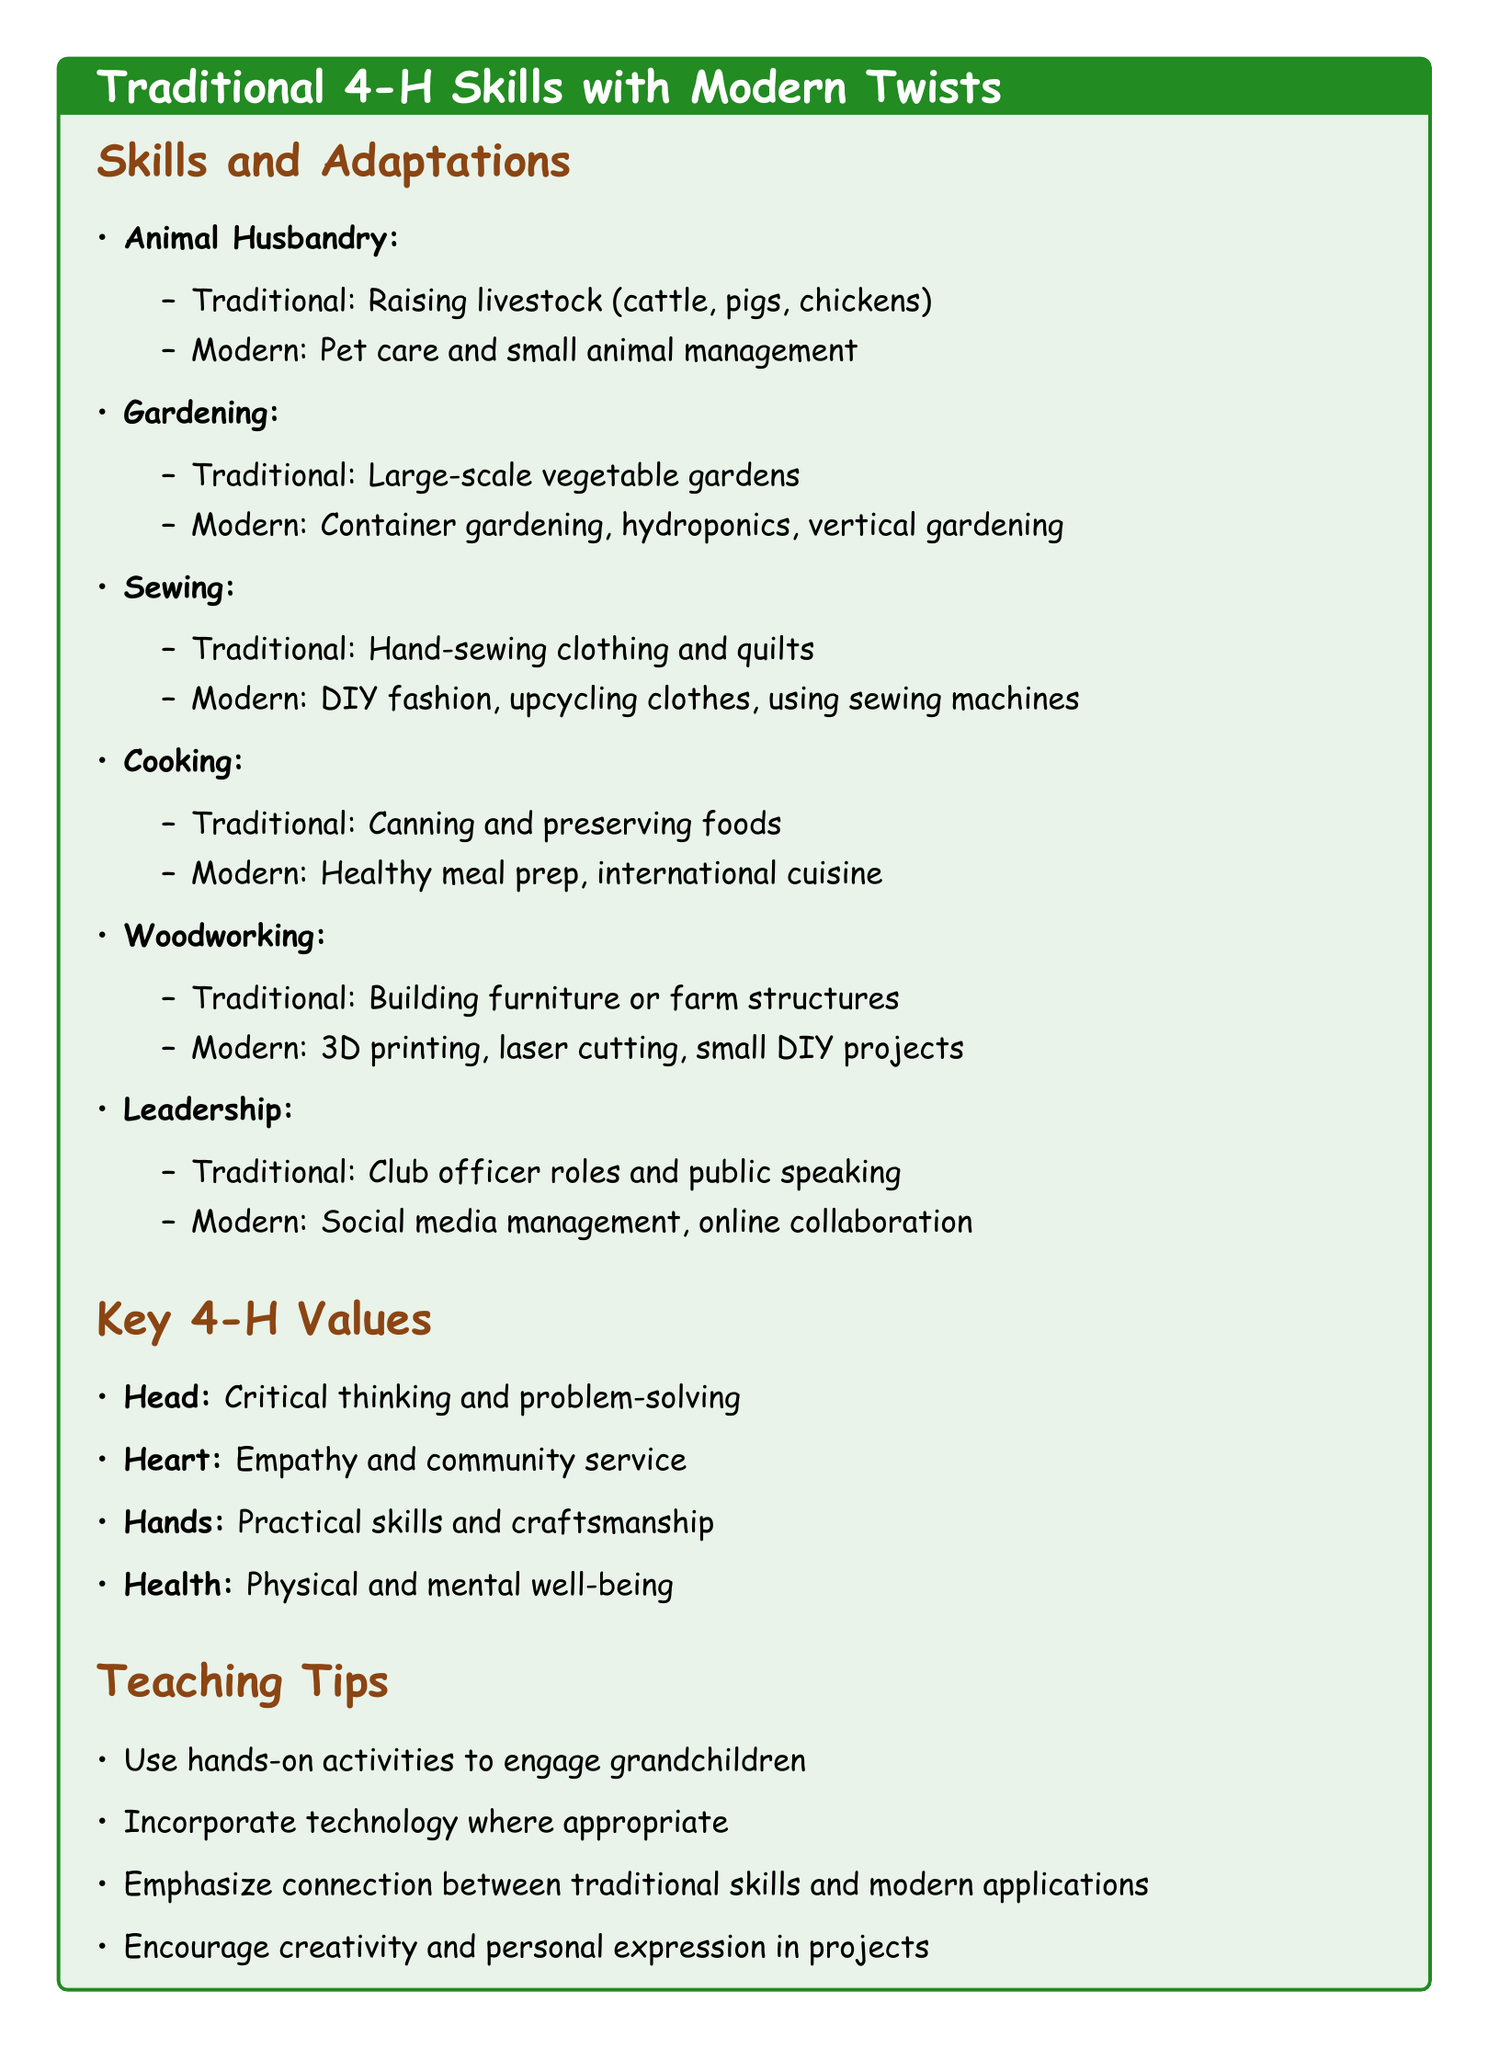What is a modern adaptation of animal husbandry? The modern adaptation mentioned is pet care and small animal management.
Answer: pet care and small animal management What traditional skill is associated with canning? Canning is associated with the traditional skill of cooking.
Answer: cooking Name one key value related to health in 4-H. The value related to health is physical and mental well-being.
Answer: physical and mental well-being What is suggested to encourage in projects? The document suggests encouraging creativity and personal expression in projects.
Answer: creativity and personal expression How many traditional skills are listed in the document? The document lists six traditional skills to teach grandchildren.
Answer: six Which modern adaptation is related to woodworking? The modern adaptation of woodworking mentioned is 3D printing.
Answer: 3D printing What is one teaching tip for engaging grandchildren? One teaching tip is to use hands-on activities to engage grandchildren.
Answer: hands-on activities Which traditional skill involves sewing? The traditional skill involving sewing is hand-sewing clothing and quilts.
Answer: hand-sewing clothing and quilts What is emphasized in teaching to connect traditional skills? The connection between traditional skills and modern applications is emphasized.
Answer: connection between traditional skills and modern applications 